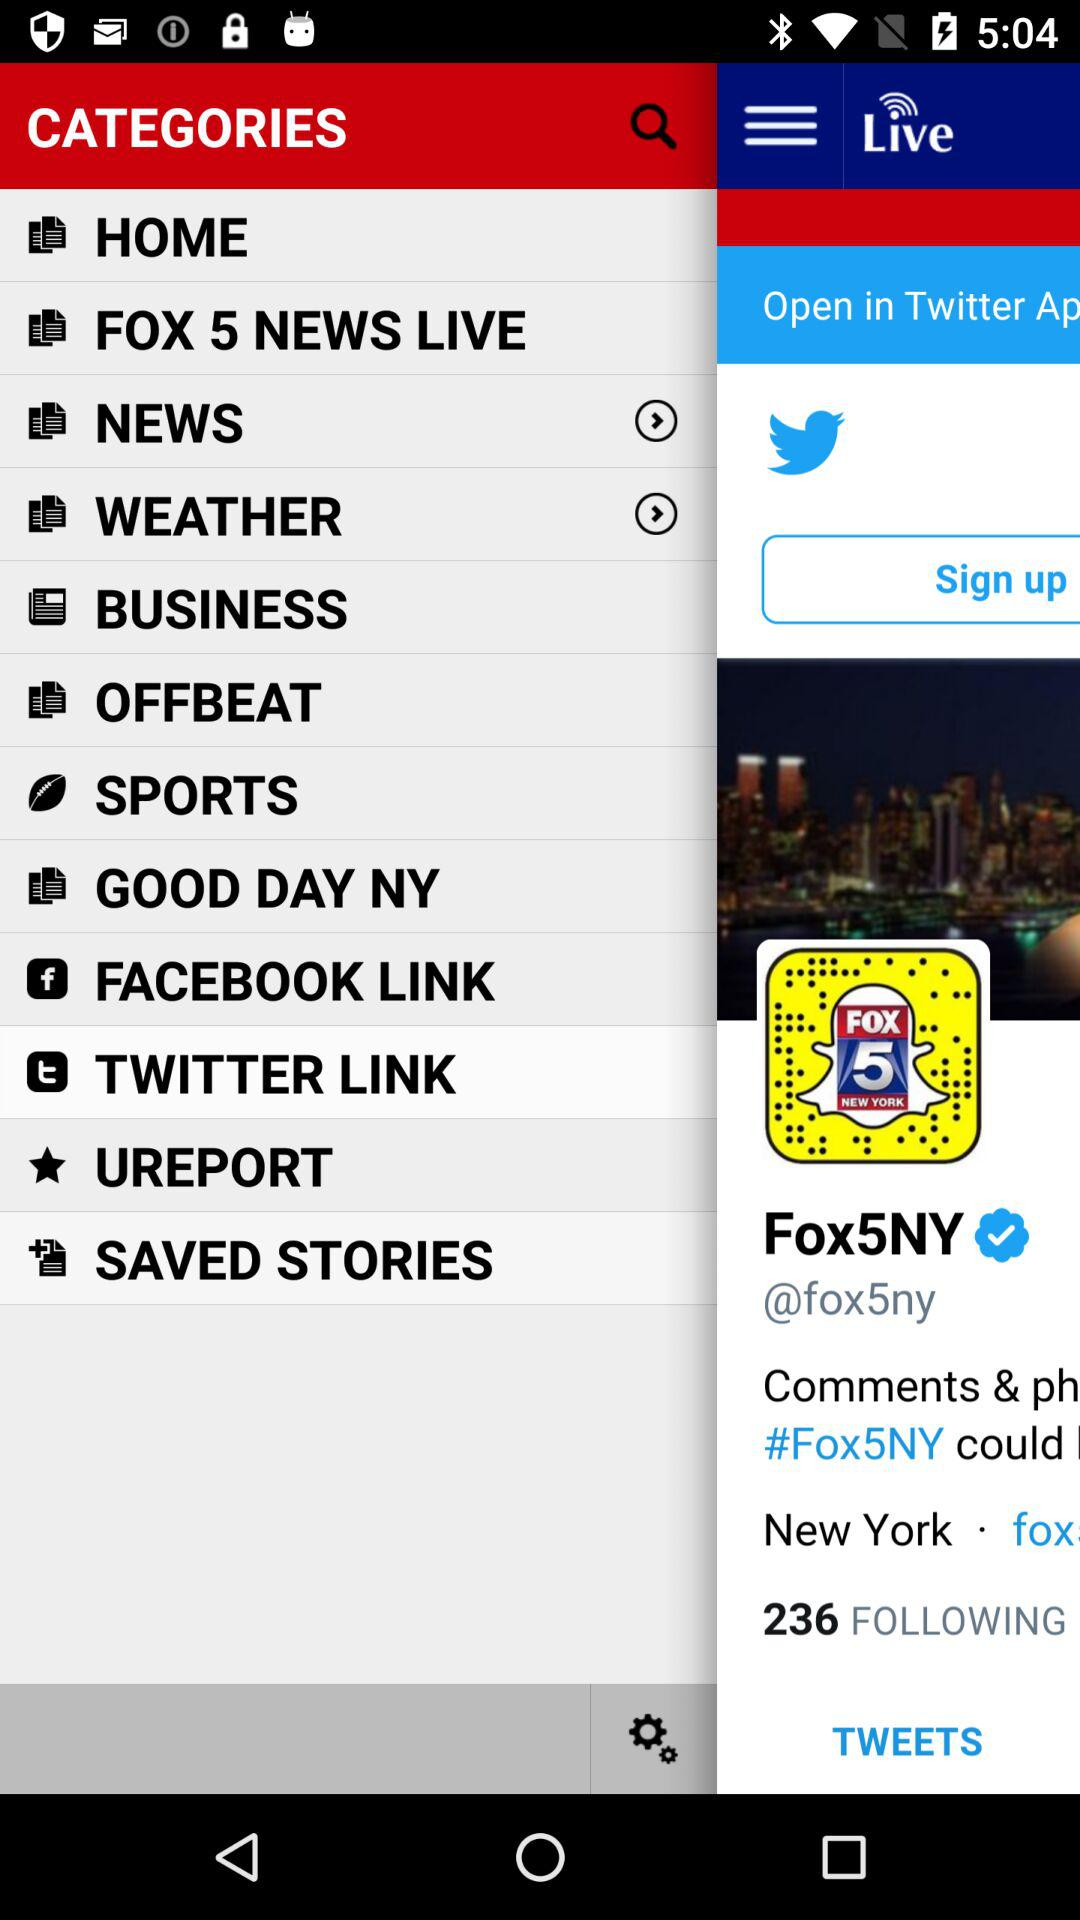What is the username? The username is "@fox5ny". 